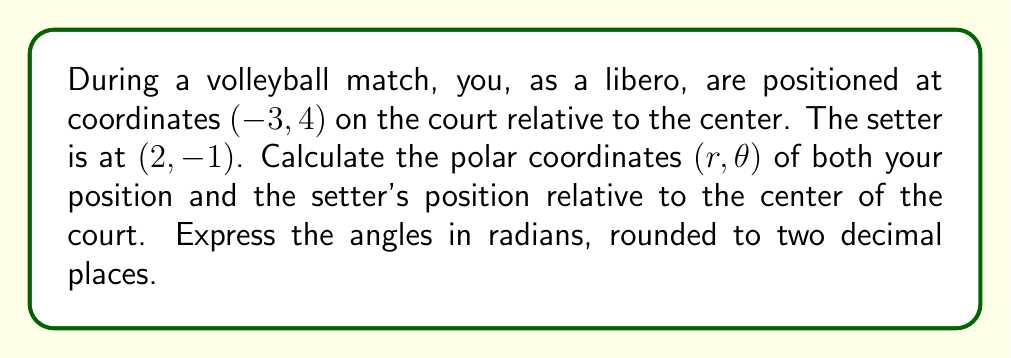Solve this math problem. To convert from Cartesian coordinates (x, y) to polar coordinates (r, θ), we use the following formulas:

1. $r = \sqrt{x^2 + y^2}$
2. $\theta = \tan^{-1}(\frac{y}{x})$

For the libero's position (-3, 4):

1. Calculate r:
   $r = \sqrt{(-3)^2 + 4^2} = \sqrt{9 + 16} = \sqrt{25} = 5$

2. Calculate θ:
   $\theta = \tan^{-1}(\frac{4}{-3}) = -0.9273$ radians
   However, since x is negative and y is positive, we need to add π to this result:
   $\theta = -0.9273 + \pi = 2.2143$ radians (rounded to 4 decimal places)

For the setter's position (2, -1):

1. Calculate r:
   $r = \sqrt{2^2 + (-1)^2} = \sqrt{4 + 1} = \sqrt{5} \approx 2.2361$

2. Calculate θ:
   $\theta = \tan^{-1}(\frac{-1}{2}) = -0.4636$ radians

Rounding the angles to two decimal places:

Libero: (5, 2.21)
Setter: (2.24, -0.46)
Answer: Libero: (5, 2.21)
Setter: (2.24, -0.46) 